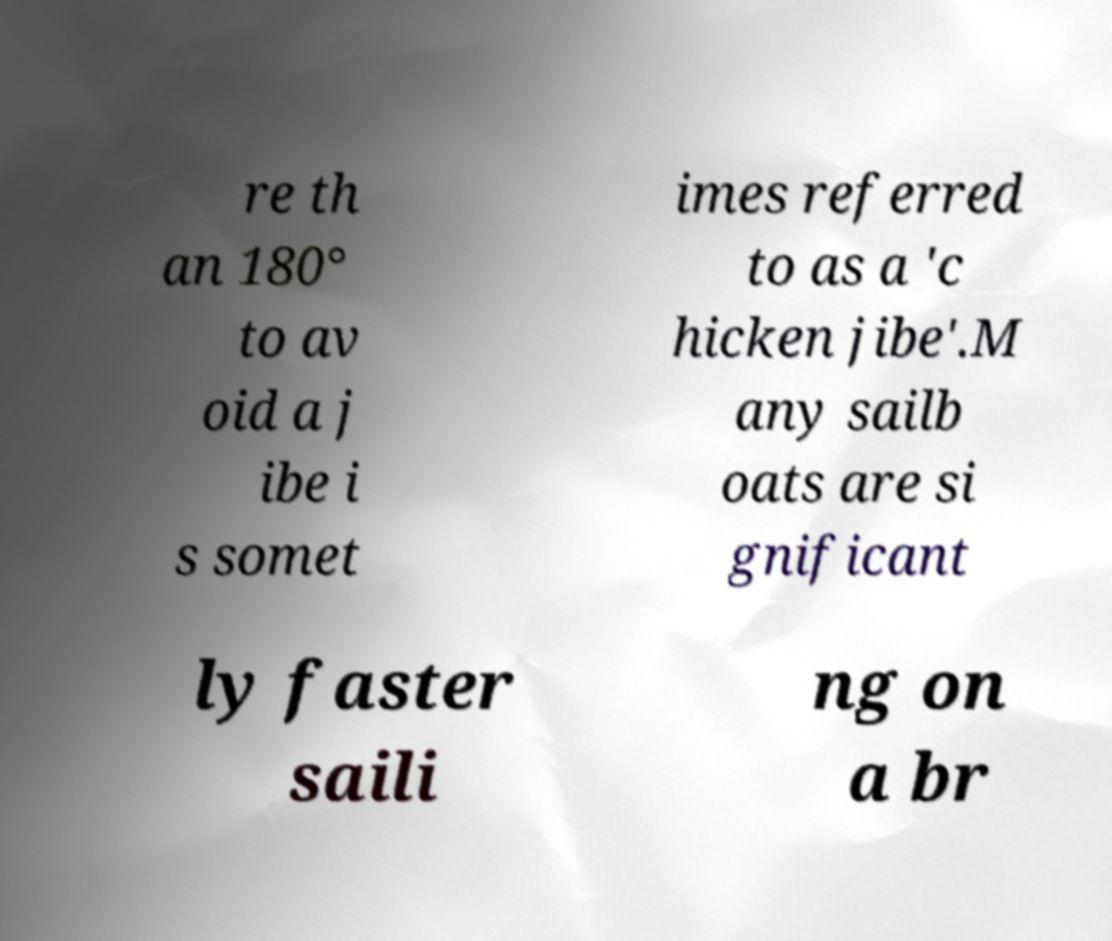I need the written content from this picture converted into text. Can you do that? re th an 180° to av oid a j ibe i s somet imes referred to as a 'c hicken jibe'.M any sailb oats are si gnificant ly faster saili ng on a br 